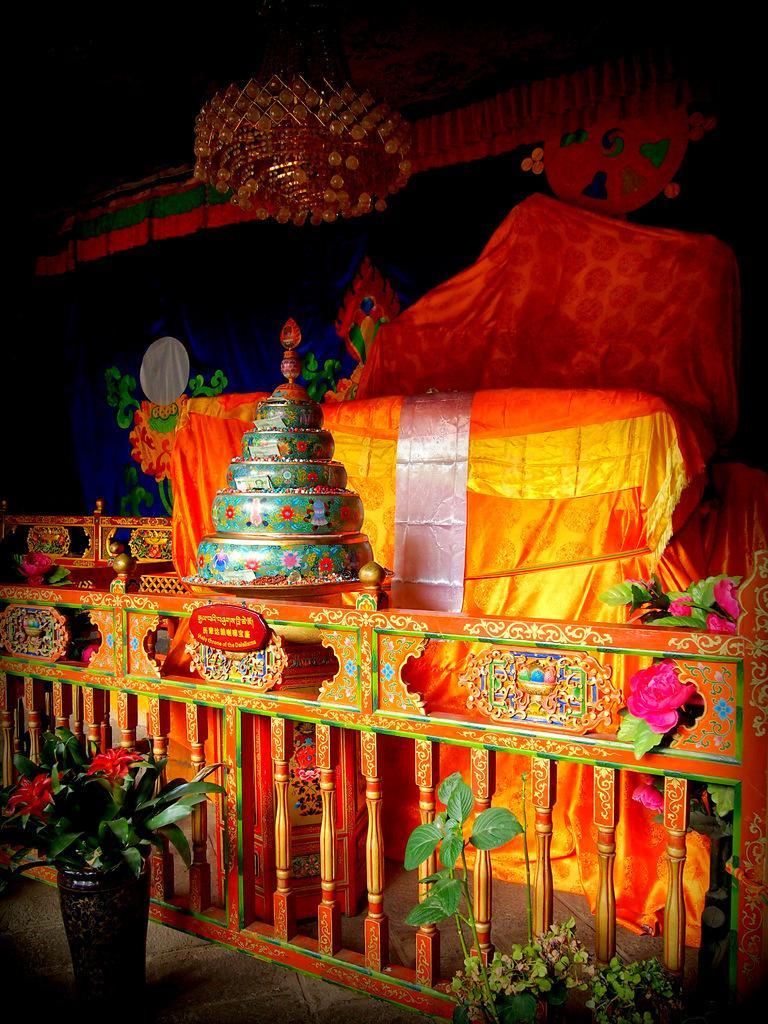In one or two sentences, can you explain what this image depicts? In this picture, there is a wooden grill at the bottom. In the center, there are some objects covered with the cloth. On the top, there is a chandelier. At the bottom, there are plants. 